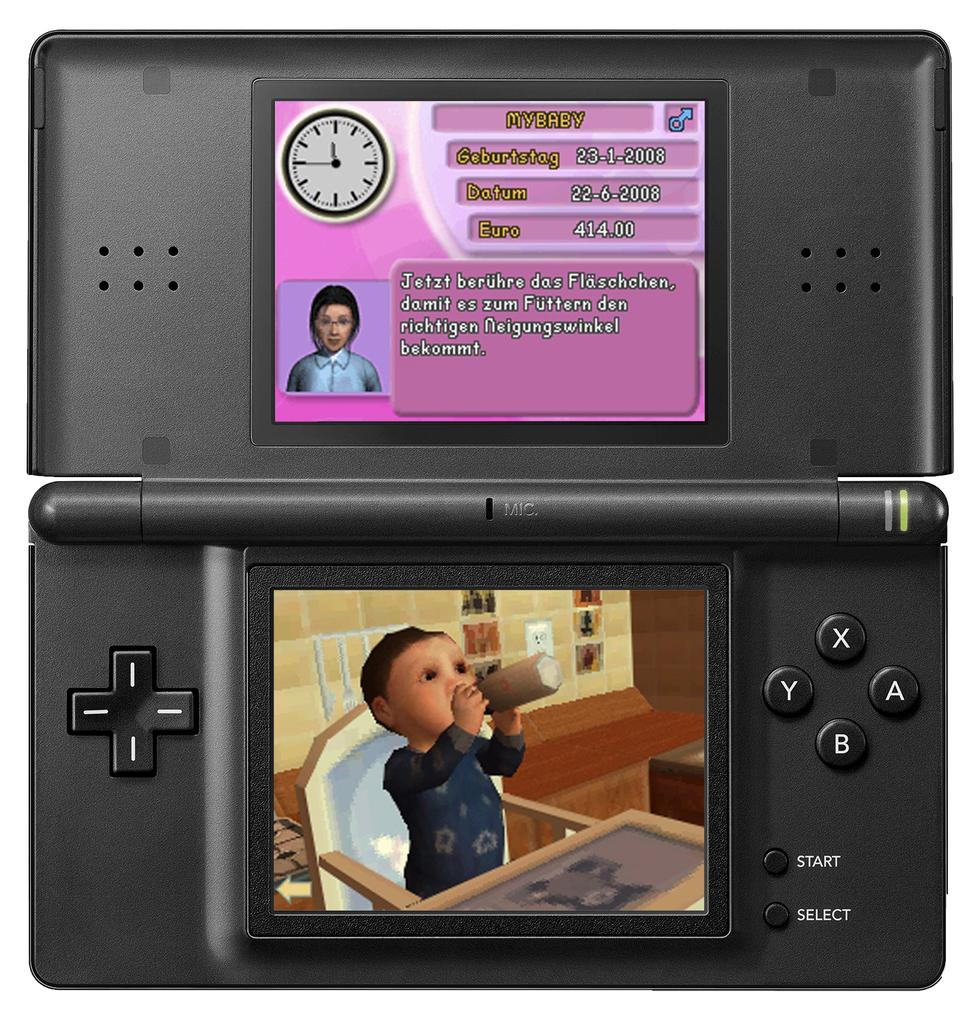What type of device is featured in the image? There is a joystick with control buttons in the image. What can be found on the joystick? The joystick has symbols and navigation buttons. What else is present in the image besides the joystick? There is a poster with text and an image in the image. What type of underwear is visible in the image? There is no underwear present in the image. What color is the lipstick on the joystick? There is no lipstick present on the joystick; it is a device with control buttons and symbols. 